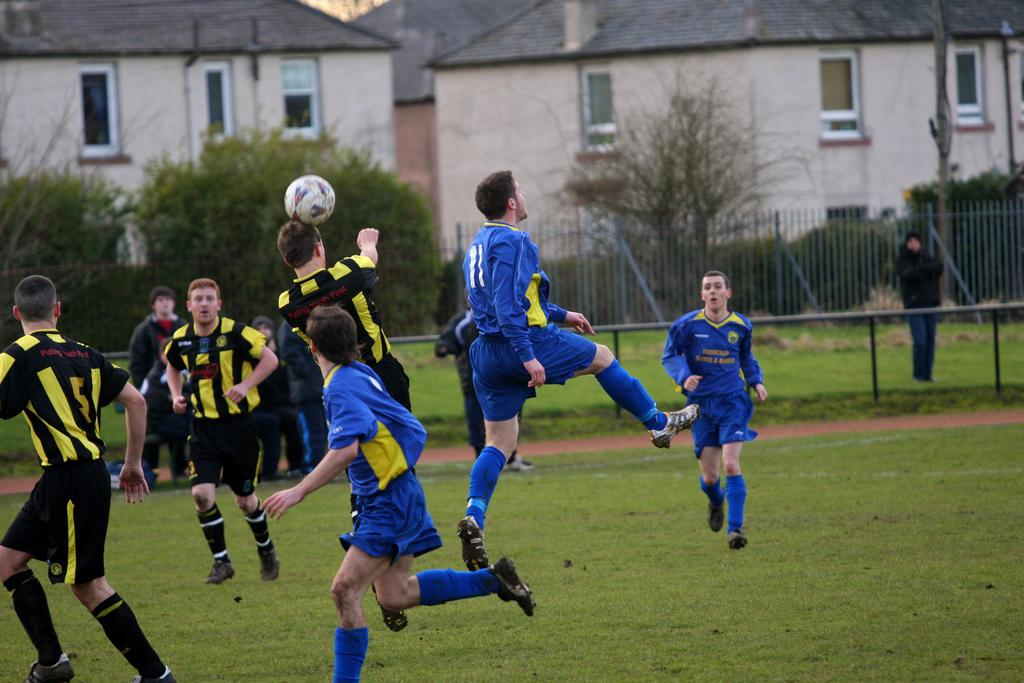What type of structure is visible in the image? There is a house in the image. What natural elements can be seen in the image? There are trees in the image. What type of barrier is present in the image? There is a fence in the image. What activity are the people engaged in on the ground? There are people playing with a ball on the ground in the image. What type of flesh can be seen hanging from the trees in the image? There is no flesh present in the image; it features a house, trees, a fence, and people playing with a ball. What type of line is visible connecting the house to the trees in the image? There is no line connecting the house to the trees in the image. 